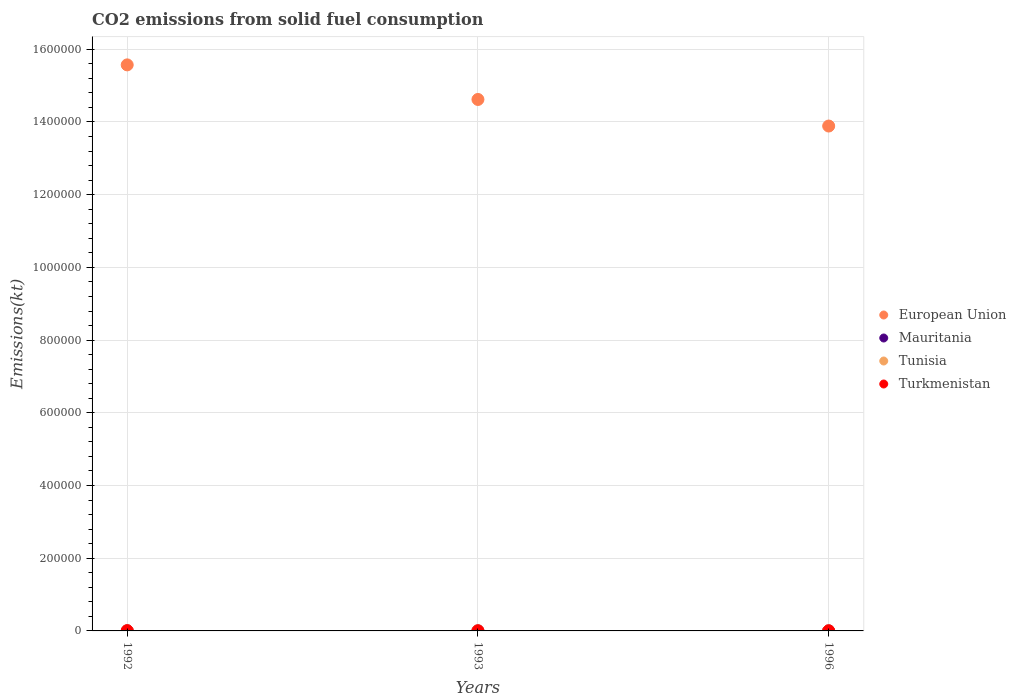Is the number of dotlines equal to the number of legend labels?
Offer a terse response. Yes. What is the amount of CO2 emitted in European Union in 1996?
Offer a terse response. 1.39e+06. Across all years, what is the maximum amount of CO2 emitted in European Union?
Your answer should be very brief. 1.56e+06. Across all years, what is the minimum amount of CO2 emitted in Tunisia?
Keep it short and to the point. 238.35. In which year was the amount of CO2 emitted in Tunisia maximum?
Ensure brevity in your answer.  1993. What is the total amount of CO2 emitted in Tunisia in the graph?
Give a very brief answer. 806.74. What is the difference between the amount of CO2 emitted in Tunisia in 1993 and the amount of CO2 emitted in Turkmenistan in 1996?
Your answer should be very brief. 25.67. What is the average amount of CO2 emitted in European Union per year?
Your answer should be very brief. 1.47e+06. In the year 1992, what is the difference between the amount of CO2 emitted in Tunisia and amount of CO2 emitted in Mauritania?
Offer a very short reply. 264.02. What is the ratio of the amount of CO2 emitted in Tunisia in 1993 to that in 1996?
Give a very brief answer. 1.22. Is the amount of CO2 emitted in Turkmenistan in 1992 less than that in 1996?
Your response must be concise. No. Is the difference between the amount of CO2 emitted in Tunisia in 1992 and 1996 greater than the difference between the amount of CO2 emitted in Mauritania in 1992 and 1996?
Offer a very short reply. Yes. What is the difference between the highest and the lowest amount of CO2 emitted in European Union?
Make the answer very short. 1.68e+05. Is the amount of CO2 emitted in Mauritania strictly greater than the amount of CO2 emitted in European Union over the years?
Make the answer very short. No. Is the amount of CO2 emitted in Turkmenistan strictly less than the amount of CO2 emitted in Tunisia over the years?
Provide a short and direct response. No. How many dotlines are there?
Provide a short and direct response. 4. How many years are there in the graph?
Ensure brevity in your answer.  3. Does the graph contain any zero values?
Offer a terse response. No. Does the graph contain grids?
Provide a short and direct response. Yes. Where does the legend appear in the graph?
Your response must be concise. Center right. How many legend labels are there?
Your response must be concise. 4. What is the title of the graph?
Your answer should be very brief. CO2 emissions from solid fuel consumption. What is the label or title of the Y-axis?
Your answer should be compact. Emissions(kt). What is the Emissions(kt) of European Union in 1992?
Make the answer very short. 1.56e+06. What is the Emissions(kt) in Mauritania in 1992?
Provide a short and direct response. 14.67. What is the Emissions(kt) of Tunisia in 1992?
Keep it short and to the point. 278.69. What is the Emissions(kt) of Turkmenistan in 1992?
Your answer should be compact. 715.07. What is the Emissions(kt) in European Union in 1993?
Ensure brevity in your answer.  1.46e+06. What is the Emissions(kt) of Mauritania in 1993?
Provide a short and direct response. 14.67. What is the Emissions(kt) of Tunisia in 1993?
Keep it short and to the point. 289.69. What is the Emissions(kt) in Turkmenistan in 1993?
Provide a succinct answer. 359.37. What is the Emissions(kt) of European Union in 1996?
Your answer should be very brief. 1.39e+06. What is the Emissions(kt) of Mauritania in 1996?
Your response must be concise. 7.33. What is the Emissions(kt) in Tunisia in 1996?
Provide a short and direct response. 238.35. What is the Emissions(kt) of Turkmenistan in 1996?
Your answer should be compact. 264.02. Across all years, what is the maximum Emissions(kt) of European Union?
Give a very brief answer. 1.56e+06. Across all years, what is the maximum Emissions(kt) in Mauritania?
Offer a terse response. 14.67. Across all years, what is the maximum Emissions(kt) of Tunisia?
Your answer should be compact. 289.69. Across all years, what is the maximum Emissions(kt) in Turkmenistan?
Provide a short and direct response. 715.07. Across all years, what is the minimum Emissions(kt) of European Union?
Make the answer very short. 1.39e+06. Across all years, what is the minimum Emissions(kt) in Mauritania?
Give a very brief answer. 7.33. Across all years, what is the minimum Emissions(kt) in Tunisia?
Ensure brevity in your answer.  238.35. Across all years, what is the minimum Emissions(kt) of Turkmenistan?
Provide a succinct answer. 264.02. What is the total Emissions(kt) in European Union in the graph?
Your response must be concise. 4.41e+06. What is the total Emissions(kt) of Mauritania in the graph?
Your answer should be compact. 36.67. What is the total Emissions(kt) of Tunisia in the graph?
Your response must be concise. 806.74. What is the total Emissions(kt) of Turkmenistan in the graph?
Your answer should be compact. 1338.45. What is the difference between the Emissions(kt) of European Union in 1992 and that in 1993?
Your response must be concise. 9.51e+04. What is the difference between the Emissions(kt) in Tunisia in 1992 and that in 1993?
Ensure brevity in your answer.  -11. What is the difference between the Emissions(kt) of Turkmenistan in 1992 and that in 1993?
Keep it short and to the point. 355.7. What is the difference between the Emissions(kt) in European Union in 1992 and that in 1996?
Give a very brief answer. 1.68e+05. What is the difference between the Emissions(kt) of Mauritania in 1992 and that in 1996?
Offer a terse response. 7.33. What is the difference between the Emissions(kt) of Tunisia in 1992 and that in 1996?
Provide a succinct answer. 40.34. What is the difference between the Emissions(kt) of Turkmenistan in 1992 and that in 1996?
Keep it short and to the point. 451.04. What is the difference between the Emissions(kt) in European Union in 1993 and that in 1996?
Give a very brief answer. 7.31e+04. What is the difference between the Emissions(kt) of Mauritania in 1993 and that in 1996?
Provide a succinct answer. 7.33. What is the difference between the Emissions(kt) in Tunisia in 1993 and that in 1996?
Keep it short and to the point. 51.34. What is the difference between the Emissions(kt) in Turkmenistan in 1993 and that in 1996?
Your answer should be very brief. 95.34. What is the difference between the Emissions(kt) in European Union in 1992 and the Emissions(kt) in Mauritania in 1993?
Provide a succinct answer. 1.56e+06. What is the difference between the Emissions(kt) in European Union in 1992 and the Emissions(kt) in Tunisia in 1993?
Offer a terse response. 1.56e+06. What is the difference between the Emissions(kt) in European Union in 1992 and the Emissions(kt) in Turkmenistan in 1993?
Keep it short and to the point. 1.56e+06. What is the difference between the Emissions(kt) of Mauritania in 1992 and the Emissions(kt) of Tunisia in 1993?
Provide a succinct answer. -275.02. What is the difference between the Emissions(kt) of Mauritania in 1992 and the Emissions(kt) of Turkmenistan in 1993?
Your response must be concise. -344.7. What is the difference between the Emissions(kt) of Tunisia in 1992 and the Emissions(kt) of Turkmenistan in 1993?
Give a very brief answer. -80.67. What is the difference between the Emissions(kt) in European Union in 1992 and the Emissions(kt) in Mauritania in 1996?
Offer a very short reply. 1.56e+06. What is the difference between the Emissions(kt) in European Union in 1992 and the Emissions(kt) in Tunisia in 1996?
Your answer should be compact. 1.56e+06. What is the difference between the Emissions(kt) in European Union in 1992 and the Emissions(kt) in Turkmenistan in 1996?
Your answer should be compact. 1.56e+06. What is the difference between the Emissions(kt) in Mauritania in 1992 and the Emissions(kt) in Tunisia in 1996?
Your answer should be very brief. -223.69. What is the difference between the Emissions(kt) of Mauritania in 1992 and the Emissions(kt) of Turkmenistan in 1996?
Your answer should be compact. -249.36. What is the difference between the Emissions(kt) of Tunisia in 1992 and the Emissions(kt) of Turkmenistan in 1996?
Keep it short and to the point. 14.67. What is the difference between the Emissions(kt) in European Union in 1993 and the Emissions(kt) in Mauritania in 1996?
Provide a succinct answer. 1.46e+06. What is the difference between the Emissions(kt) of European Union in 1993 and the Emissions(kt) of Tunisia in 1996?
Give a very brief answer. 1.46e+06. What is the difference between the Emissions(kt) in European Union in 1993 and the Emissions(kt) in Turkmenistan in 1996?
Your answer should be compact. 1.46e+06. What is the difference between the Emissions(kt) in Mauritania in 1993 and the Emissions(kt) in Tunisia in 1996?
Keep it short and to the point. -223.69. What is the difference between the Emissions(kt) in Mauritania in 1993 and the Emissions(kt) in Turkmenistan in 1996?
Your response must be concise. -249.36. What is the difference between the Emissions(kt) in Tunisia in 1993 and the Emissions(kt) in Turkmenistan in 1996?
Keep it short and to the point. 25.67. What is the average Emissions(kt) in European Union per year?
Ensure brevity in your answer.  1.47e+06. What is the average Emissions(kt) of Mauritania per year?
Your answer should be compact. 12.22. What is the average Emissions(kt) of Tunisia per year?
Keep it short and to the point. 268.91. What is the average Emissions(kt) in Turkmenistan per year?
Ensure brevity in your answer.  446.15. In the year 1992, what is the difference between the Emissions(kt) of European Union and Emissions(kt) of Mauritania?
Make the answer very short. 1.56e+06. In the year 1992, what is the difference between the Emissions(kt) of European Union and Emissions(kt) of Tunisia?
Provide a succinct answer. 1.56e+06. In the year 1992, what is the difference between the Emissions(kt) in European Union and Emissions(kt) in Turkmenistan?
Provide a succinct answer. 1.56e+06. In the year 1992, what is the difference between the Emissions(kt) in Mauritania and Emissions(kt) in Tunisia?
Your answer should be compact. -264.02. In the year 1992, what is the difference between the Emissions(kt) in Mauritania and Emissions(kt) in Turkmenistan?
Ensure brevity in your answer.  -700.4. In the year 1992, what is the difference between the Emissions(kt) of Tunisia and Emissions(kt) of Turkmenistan?
Keep it short and to the point. -436.37. In the year 1993, what is the difference between the Emissions(kt) in European Union and Emissions(kt) in Mauritania?
Make the answer very short. 1.46e+06. In the year 1993, what is the difference between the Emissions(kt) in European Union and Emissions(kt) in Tunisia?
Provide a succinct answer. 1.46e+06. In the year 1993, what is the difference between the Emissions(kt) in European Union and Emissions(kt) in Turkmenistan?
Offer a very short reply. 1.46e+06. In the year 1993, what is the difference between the Emissions(kt) in Mauritania and Emissions(kt) in Tunisia?
Your answer should be compact. -275.02. In the year 1993, what is the difference between the Emissions(kt) of Mauritania and Emissions(kt) of Turkmenistan?
Your response must be concise. -344.7. In the year 1993, what is the difference between the Emissions(kt) in Tunisia and Emissions(kt) in Turkmenistan?
Your answer should be compact. -69.67. In the year 1996, what is the difference between the Emissions(kt) of European Union and Emissions(kt) of Mauritania?
Ensure brevity in your answer.  1.39e+06. In the year 1996, what is the difference between the Emissions(kt) in European Union and Emissions(kt) in Tunisia?
Your answer should be very brief. 1.39e+06. In the year 1996, what is the difference between the Emissions(kt) in European Union and Emissions(kt) in Turkmenistan?
Ensure brevity in your answer.  1.39e+06. In the year 1996, what is the difference between the Emissions(kt) in Mauritania and Emissions(kt) in Tunisia?
Your answer should be very brief. -231.02. In the year 1996, what is the difference between the Emissions(kt) in Mauritania and Emissions(kt) in Turkmenistan?
Ensure brevity in your answer.  -256.69. In the year 1996, what is the difference between the Emissions(kt) in Tunisia and Emissions(kt) in Turkmenistan?
Give a very brief answer. -25.67. What is the ratio of the Emissions(kt) in European Union in 1992 to that in 1993?
Offer a very short reply. 1.07. What is the ratio of the Emissions(kt) of Turkmenistan in 1992 to that in 1993?
Offer a terse response. 1.99. What is the ratio of the Emissions(kt) in European Union in 1992 to that in 1996?
Your answer should be very brief. 1.12. What is the ratio of the Emissions(kt) in Tunisia in 1992 to that in 1996?
Make the answer very short. 1.17. What is the ratio of the Emissions(kt) in Turkmenistan in 1992 to that in 1996?
Keep it short and to the point. 2.71. What is the ratio of the Emissions(kt) in European Union in 1993 to that in 1996?
Provide a succinct answer. 1.05. What is the ratio of the Emissions(kt) in Tunisia in 1993 to that in 1996?
Your response must be concise. 1.22. What is the ratio of the Emissions(kt) in Turkmenistan in 1993 to that in 1996?
Provide a short and direct response. 1.36. What is the difference between the highest and the second highest Emissions(kt) in European Union?
Ensure brevity in your answer.  9.51e+04. What is the difference between the highest and the second highest Emissions(kt) of Mauritania?
Offer a terse response. 0. What is the difference between the highest and the second highest Emissions(kt) of Tunisia?
Your answer should be compact. 11. What is the difference between the highest and the second highest Emissions(kt) in Turkmenistan?
Keep it short and to the point. 355.7. What is the difference between the highest and the lowest Emissions(kt) of European Union?
Your answer should be compact. 1.68e+05. What is the difference between the highest and the lowest Emissions(kt) of Mauritania?
Offer a very short reply. 7.33. What is the difference between the highest and the lowest Emissions(kt) of Tunisia?
Provide a short and direct response. 51.34. What is the difference between the highest and the lowest Emissions(kt) in Turkmenistan?
Your answer should be very brief. 451.04. 